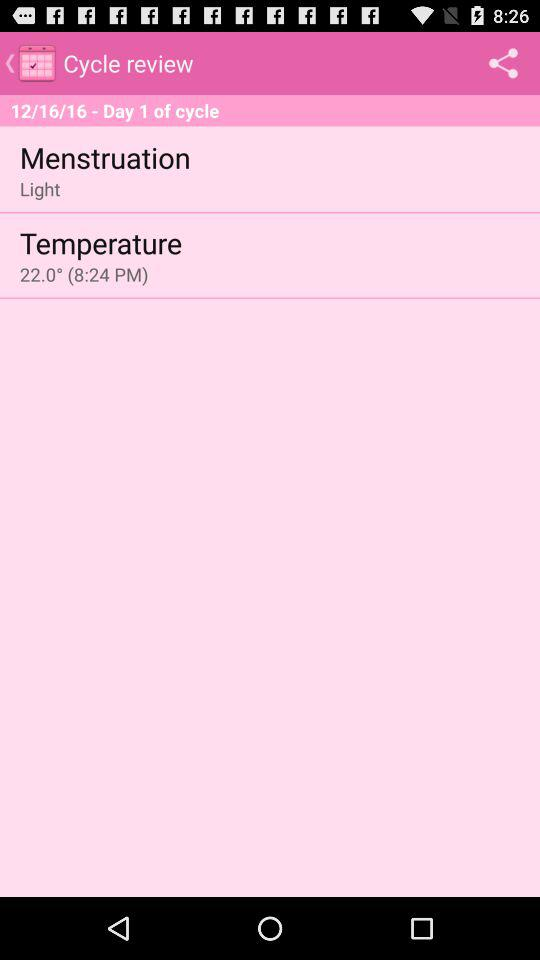How is the menstruation? The menstruation is light. 